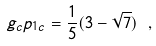Convert formula to latex. <formula><loc_0><loc_0><loc_500><loc_500>g _ { c } p _ { 1 c } = \frac { 1 } { 5 } ( { 3 - \sqrt { 7 } } ) \ ,</formula> 